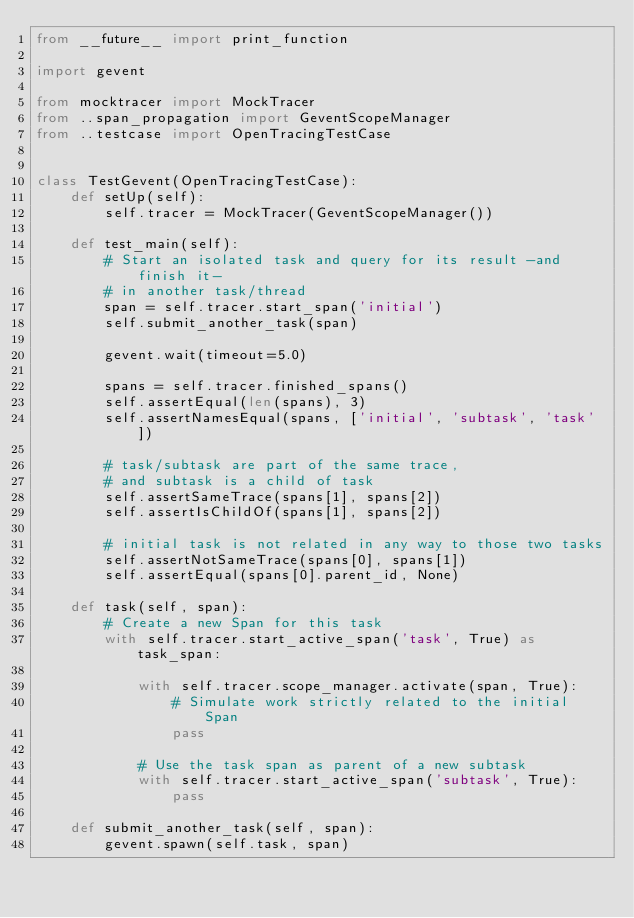Convert code to text. <code><loc_0><loc_0><loc_500><loc_500><_Python_>from __future__ import print_function

import gevent

from mocktracer import MockTracer
from ..span_propagation import GeventScopeManager
from ..testcase import OpenTracingTestCase


class TestGevent(OpenTracingTestCase):
    def setUp(self):
        self.tracer = MockTracer(GeventScopeManager())

    def test_main(self):
        # Start an isolated task and query for its result -and finish it-
        # in another task/thread
        span = self.tracer.start_span('initial')
        self.submit_another_task(span)

        gevent.wait(timeout=5.0)

        spans = self.tracer.finished_spans()
        self.assertEqual(len(spans), 3)
        self.assertNamesEqual(spans, ['initial', 'subtask', 'task'])

        # task/subtask are part of the same trace,
        # and subtask is a child of task
        self.assertSameTrace(spans[1], spans[2])
        self.assertIsChildOf(spans[1], spans[2])

        # initial task is not related in any way to those two tasks
        self.assertNotSameTrace(spans[0], spans[1])
        self.assertEqual(spans[0].parent_id, None)

    def task(self, span):
        # Create a new Span for this task
        with self.tracer.start_active_span('task', True) as task_span:

            with self.tracer.scope_manager.activate(span, True):
                # Simulate work strictly related to the initial Span
                pass

            # Use the task span as parent of a new subtask
            with self.tracer.start_active_span('subtask', True):
                pass

    def submit_another_task(self, span):
        gevent.spawn(self.task, span)
</code> 